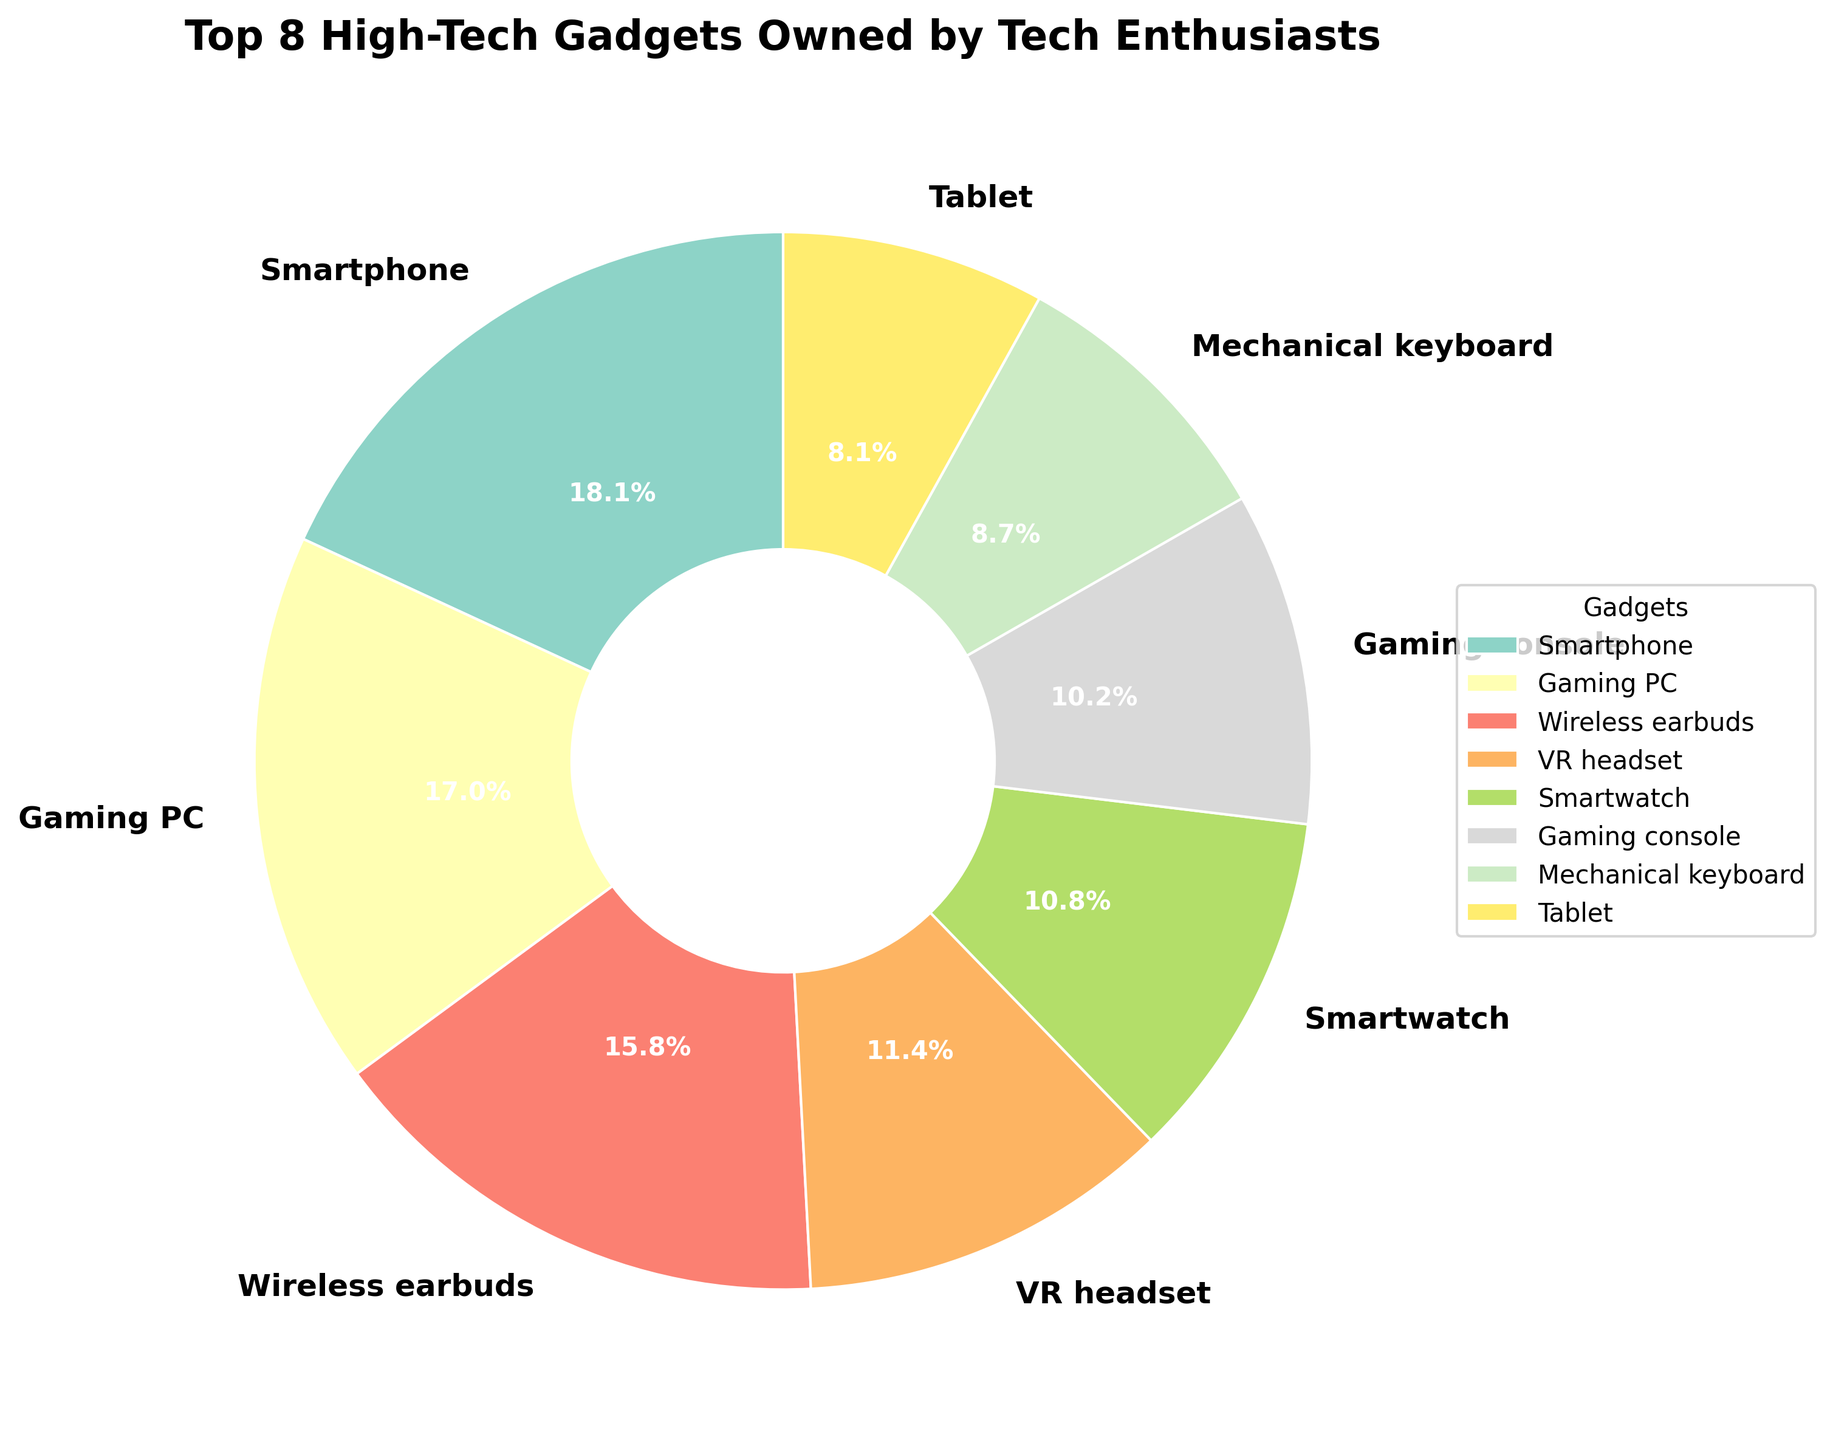Which gadget has the highest ownership percentage among tech enthusiasts? The slice representing smartphones is the largest, and the label shows 98.5%.
Answer: Smartphone How much higher is the ownership percentage of Wireless Earbuds compared to Gaming Consoles? Wireless earbuds have a percentage of 85.7%, and gaming consoles have 55.4%. Subtracting 55.4 from 85.7 gives the difference.
Answer: 30.3% Which gadget is owned by more tech enthusiasts: a VR headset or a Smartwatch? By comparing the slices and labels, the VR headset shows 62.1% and the smartwatch shows 58.9%.
Answer: VR headset What is the combined ownership percentage of the top two gadgets? The top two gadgets are the smartphone (98.5%) and the gaming PC (92.3%). Adding these percentages gives the combined value.
Answer: 190.8% Which two gadgets have the closest ownership percentages? Among the top eight, the smartwatch (58.9%) and the gaming console (55.4%) have the closest percentages.
Answer: Smartwatch and Gaming console What is the difference in ownership percentage between the most and least owned gadgets in the top 8? The most owned gadget is the smartphone (98.5%) and the least owned in the top 8 is the tablet (43.8%). Subtracting 43.8 from 98.5 gives the difference.
Answer: 54.7% Which gadget's slice has more visual space: the Gaming PC or the Mechanical Keyboard? The Gaming PC slice is significantly larger than the Mechanical Keyboard's, indicating a higher percentage of ownership.
Answer: Gaming PC How does the ownership of Smart Home Assistant compare to that of Noise-canceling Headphones? The Smart Home Assistant (33.2%) is not in the top eight while Noise-canceling Headphones (36.8%) are not visualized, but from the data, Noise-canceling Headphones have a slightly higher ownership.
Answer: Noise-canceling Headphones What percentage of tech enthusiasts own either a 4K Monitor or a Streaming Device? The 4K Monitor (41.6%) is not in the top eight, nor is the Streaming Device (39.5%), but adding these gives their combined ownership value.
Answer: 81.1% 